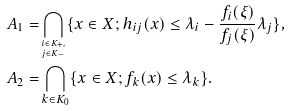Convert formula to latex. <formula><loc_0><loc_0><loc_500><loc_500>A _ { 1 } = & \bigcap _ { ^ { i \in K _ { + } , } _ { j \in K _ { - } } } \{ x \in X ; h _ { i j } ( x ) \leq \lambda _ { i } - \frac { f _ { i } ( \xi ) } { f _ { j } ( \xi ) } \lambda _ { j } \} , \\ A _ { 2 } = & \bigcap _ { k \in K _ { 0 } } \{ x \in X ; f _ { k } ( x ) \leq \lambda _ { k } \} .</formula> 